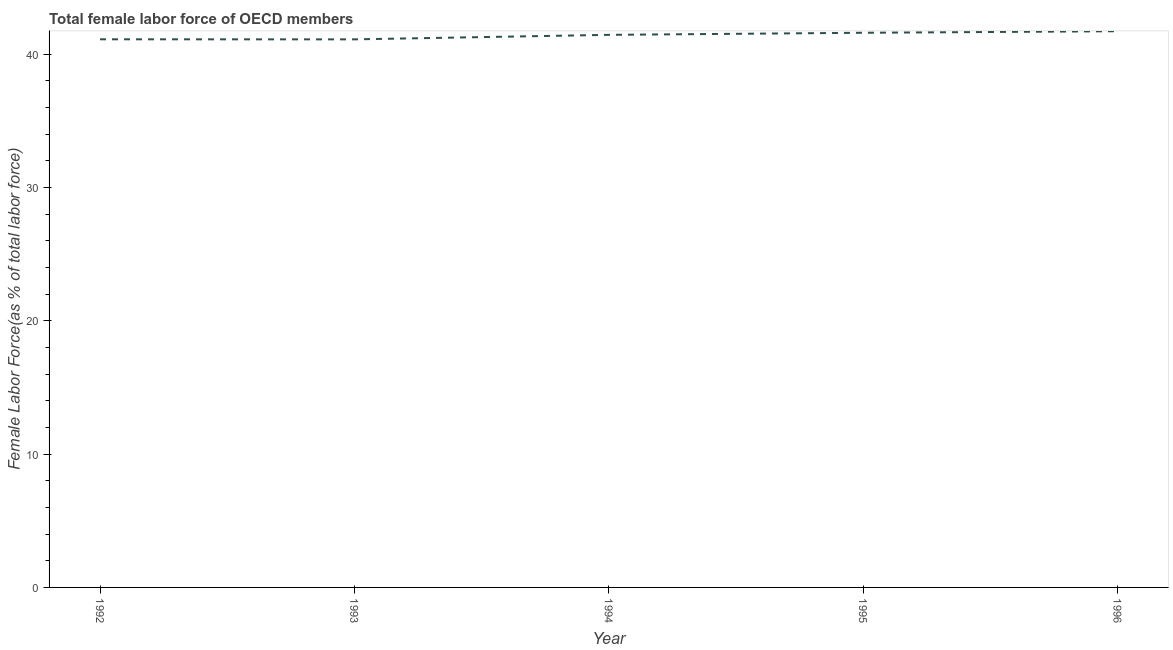What is the total female labor force in 1993?
Provide a short and direct response. 41.11. Across all years, what is the maximum total female labor force?
Give a very brief answer. 41.72. Across all years, what is the minimum total female labor force?
Your response must be concise. 41.11. In which year was the total female labor force minimum?
Offer a terse response. 1993. What is the sum of the total female labor force?
Your answer should be compact. 206.98. What is the difference between the total female labor force in 1995 and 1996?
Provide a short and direct response. -0.12. What is the average total female labor force per year?
Make the answer very short. 41.4. What is the median total female labor force?
Your response must be concise. 41.44. In how many years, is the total female labor force greater than 8 %?
Offer a very short reply. 5. Do a majority of the years between 1996 and 1992 (inclusive) have total female labor force greater than 12 %?
Provide a succinct answer. Yes. What is the ratio of the total female labor force in 1992 to that in 1995?
Provide a short and direct response. 0.99. Is the total female labor force in 1993 less than that in 1995?
Your response must be concise. Yes. Is the difference between the total female labor force in 1992 and 1995 greater than the difference between any two years?
Give a very brief answer. No. What is the difference between the highest and the second highest total female labor force?
Offer a very short reply. 0.12. What is the difference between the highest and the lowest total female labor force?
Make the answer very short. 0.61. In how many years, is the total female labor force greater than the average total female labor force taken over all years?
Offer a very short reply. 3. How many lines are there?
Give a very brief answer. 1. What is the difference between two consecutive major ticks on the Y-axis?
Provide a short and direct response. 10. Are the values on the major ticks of Y-axis written in scientific E-notation?
Your answer should be very brief. No. Does the graph contain any zero values?
Make the answer very short. No. Does the graph contain grids?
Your response must be concise. No. What is the title of the graph?
Provide a short and direct response. Total female labor force of OECD members. What is the label or title of the X-axis?
Make the answer very short. Year. What is the label or title of the Y-axis?
Make the answer very short. Female Labor Force(as % of total labor force). What is the Female Labor Force(as % of total labor force) in 1992?
Offer a very short reply. 41.11. What is the Female Labor Force(as % of total labor force) of 1993?
Give a very brief answer. 41.11. What is the Female Labor Force(as % of total labor force) in 1994?
Keep it short and to the point. 41.44. What is the Female Labor Force(as % of total labor force) in 1995?
Your answer should be compact. 41.6. What is the Female Labor Force(as % of total labor force) in 1996?
Your answer should be compact. 41.72. What is the difference between the Female Labor Force(as % of total labor force) in 1992 and 1993?
Your answer should be compact. 0.01. What is the difference between the Female Labor Force(as % of total labor force) in 1992 and 1994?
Make the answer very short. -0.33. What is the difference between the Female Labor Force(as % of total labor force) in 1992 and 1995?
Offer a terse response. -0.49. What is the difference between the Female Labor Force(as % of total labor force) in 1992 and 1996?
Your answer should be compact. -0.6. What is the difference between the Female Labor Force(as % of total labor force) in 1993 and 1994?
Your answer should be compact. -0.34. What is the difference between the Female Labor Force(as % of total labor force) in 1993 and 1995?
Your answer should be very brief. -0.49. What is the difference between the Female Labor Force(as % of total labor force) in 1993 and 1996?
Your answer should be very brief. -0.61. What is the difference between the Female Labor Force(as % of total labor force) in 1994 and 1995?
Give a very brief answer. -0.16. What is the difference between the Female Labor Force(as % of total labor force) in 1994 and 1996?
Your response must be concise. -0.27. What is the difference between the Female Labor Force(as % of total labor force) in 1995 and 1996?
Provide a short and direct response. -0.12. What is the ratio of the Female Labor Force(as % of total labor force) in 1992 to that in 1994?
Provide a succinct answer. 0.99. What is the ratio of the Female Labor Force(as % of total labor force) in 1993 to that in 1996?
Give a very brief answer. 0.98. What is the ratio of the Female Labor Force(as % of total labor force) in 1994 to that in 1996?
Keep it short and to the point. 0.99. What is the ratio of the Female Labor Force(as % of total labor force) in 1995 to that in 1996?
Give a very brief answer. 1. 